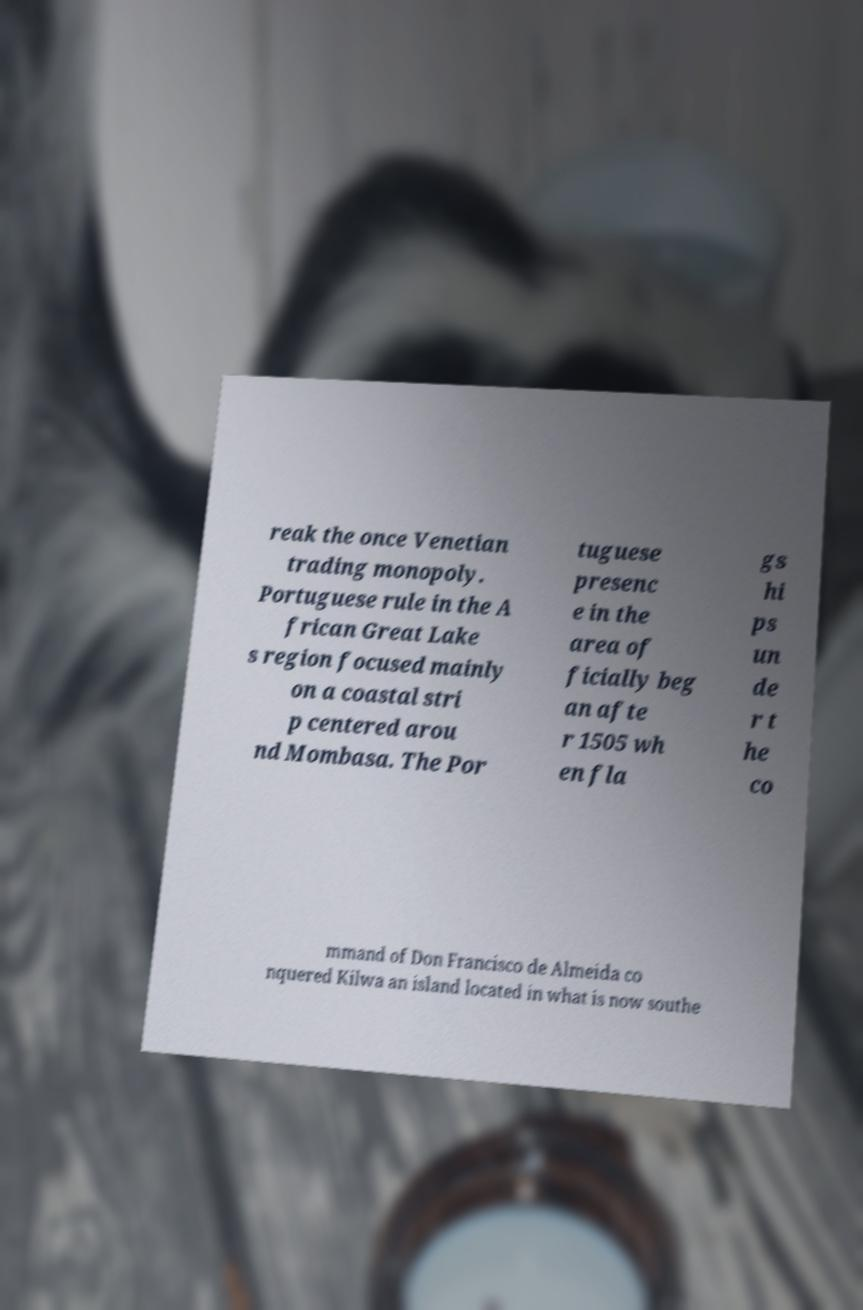Please identify and transcribe the text found in this image. reak the once Venetian trading monopoly. Portuguese rule in the A frican Great Lake s region focused mainly on a coastal stri p centered arou nd Mombasa. The Por tuguese presenc e in the area of ficially beg an afte r 1505 wh en fla gs hi ps un de r t he co mmand of Don Francisco de Almeida co nquered Kilwa an island located in what is now southe 